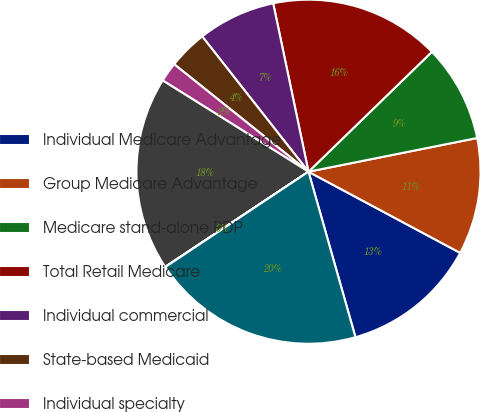Convert chart. <chart><loc_0><loc_0><loc_500><loc_500><pie_chart><fcel>Individual Medicare Advantage<fcel>Group Medicare Advantage<fcel>Medicare stand-alone PDP<fcel>Total Retail Medicare<fcel>Individual commercial<fcel>State-based Medicaid<fcel>Individual specialty<fcel>Total premiums<fcel>Services<fcel>Total premiums and services<nl><fcel>12.78%<fcel>10.96%<fcel>9.13%<fcel>16.02%<fcel>7.31%<fcel>3.66%<fcel>1.84%<fcel>18.23%<fcel>0.02%<fcel>20.05%<nl></chart> 